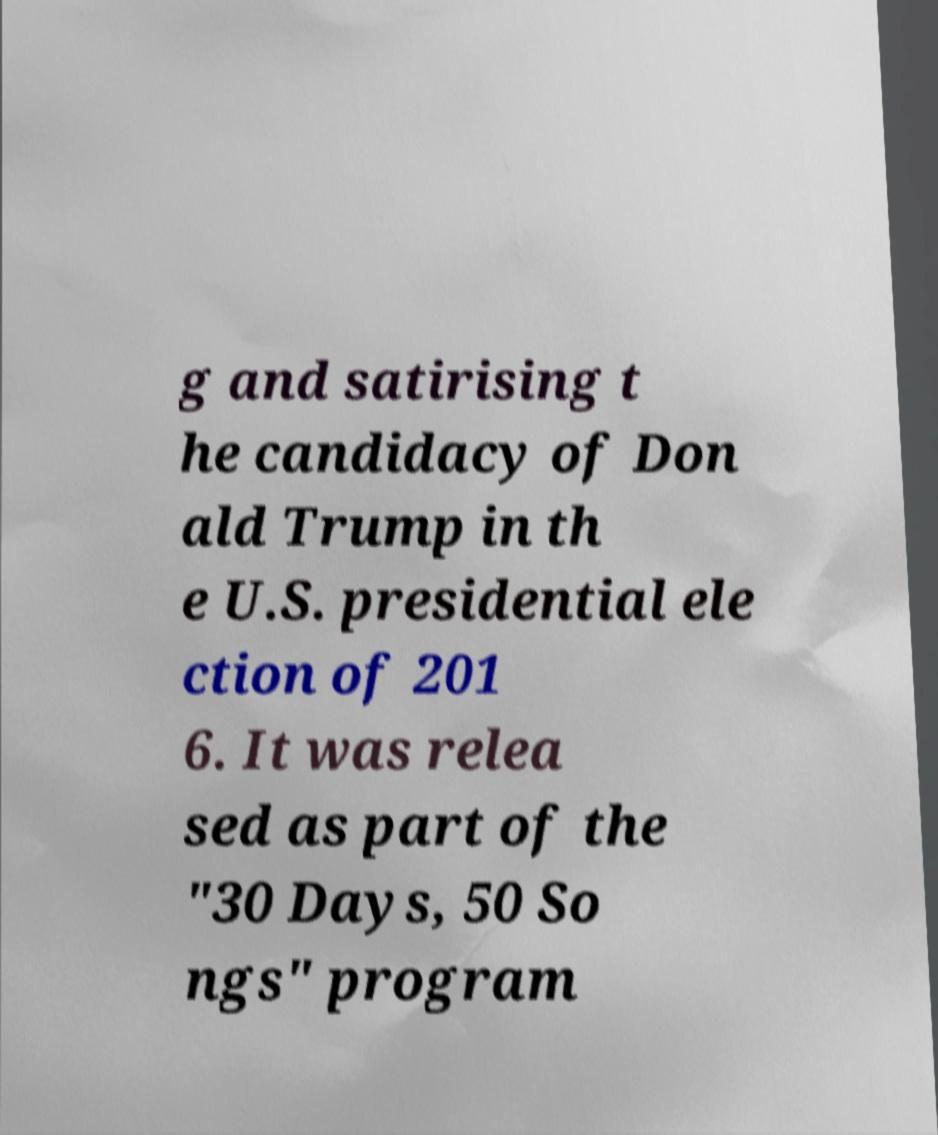There's text embedded in this image that I need extracted. Can you transcribe it verbatim? g and satirising t he candidacy of Don ald Trump in th e U.S. presidential ele ction of 201 6. It was relea sed as part of the "30 Days, 50 So ngs" program 